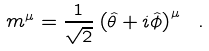<formula> <loc_0><loc_0><loc_500><loc_500>m ^ { \mu } = { \frac { 1 } { \sqrt { 2 } } } \left ( { \hat { \theta } } + i { \hat { \phi } } \right ) ^ { \mu } \ .</formula> 